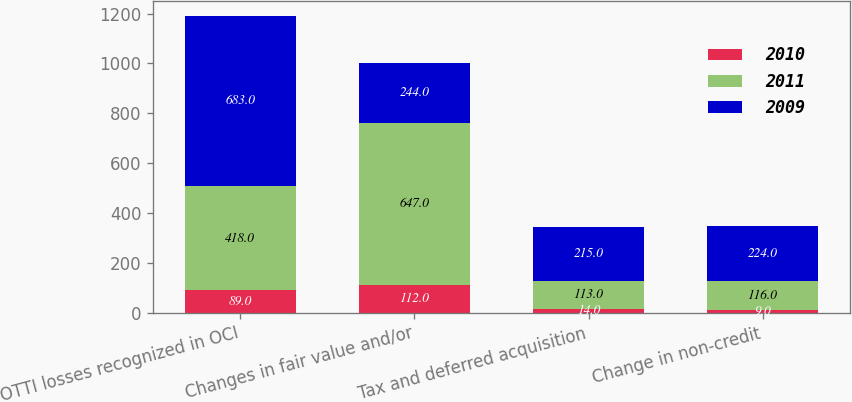Convert chart. <chart><loc_0><loc_0><loc_500><loc_500><stacked_bar_chart><ecel><fcel>OTTI losses recognized in OCI<fcel>Changes in fair value and/or<fcel>Tax and deferred acquisition<fcel>Change in non-credit<nl><fcel>2010<fcel>89<fcel>112<fcel>14<fcel>9<nl><fcel>2011<fcel>418<fcel>647<fcel>113<fcel>116<nl><fcel>2009<fcel>683<fcel>244<fcel>215<fcel>224<nl></chart> 